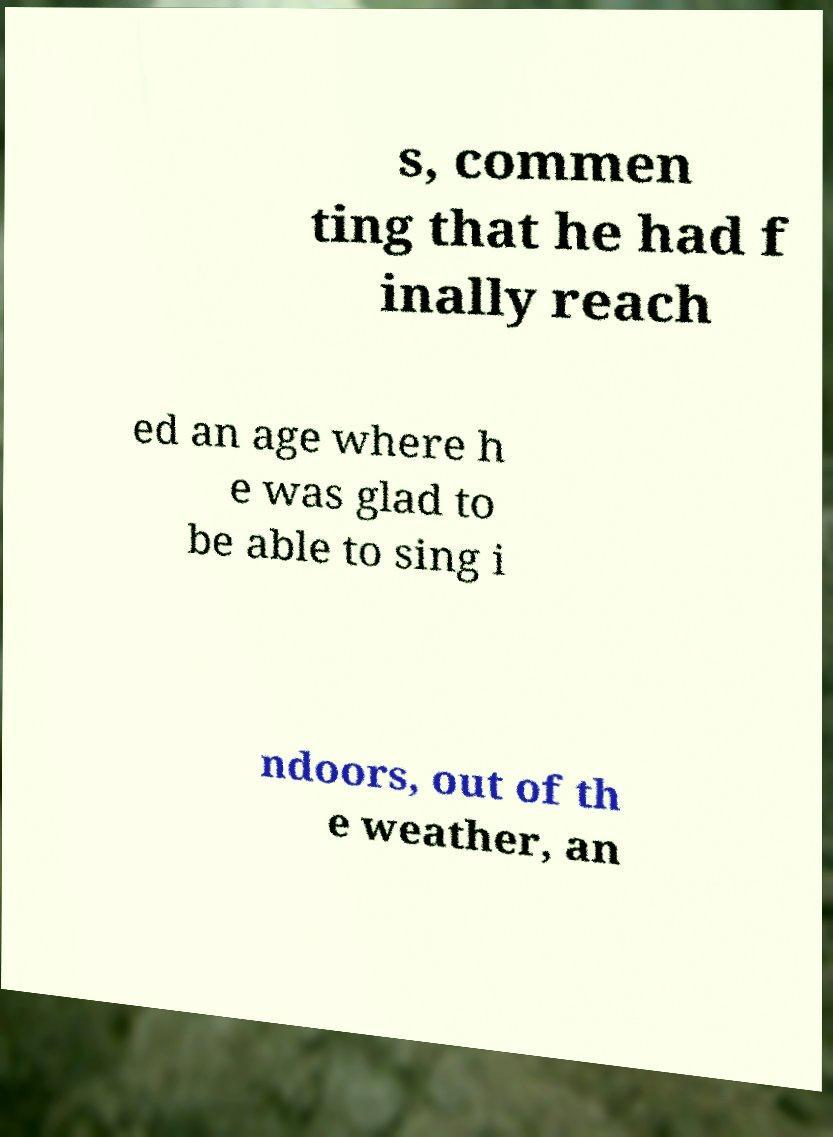For documentation purposes, I need the text within this image transcribed. Could you provide that? s, commen ting that he had f inally reach ed an age where h e was glad to be able to sing i ndoors, out of th e weather, an 